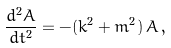Convert formula to latex. <formula><loc_0><loc_0><loc_500><loc_500>\frac { d ^ { 2 } A } { d t ^ { 2 } } = - ( k ^ { 2 } + m ^ { 2 } ) \, A \, ,</formula> 